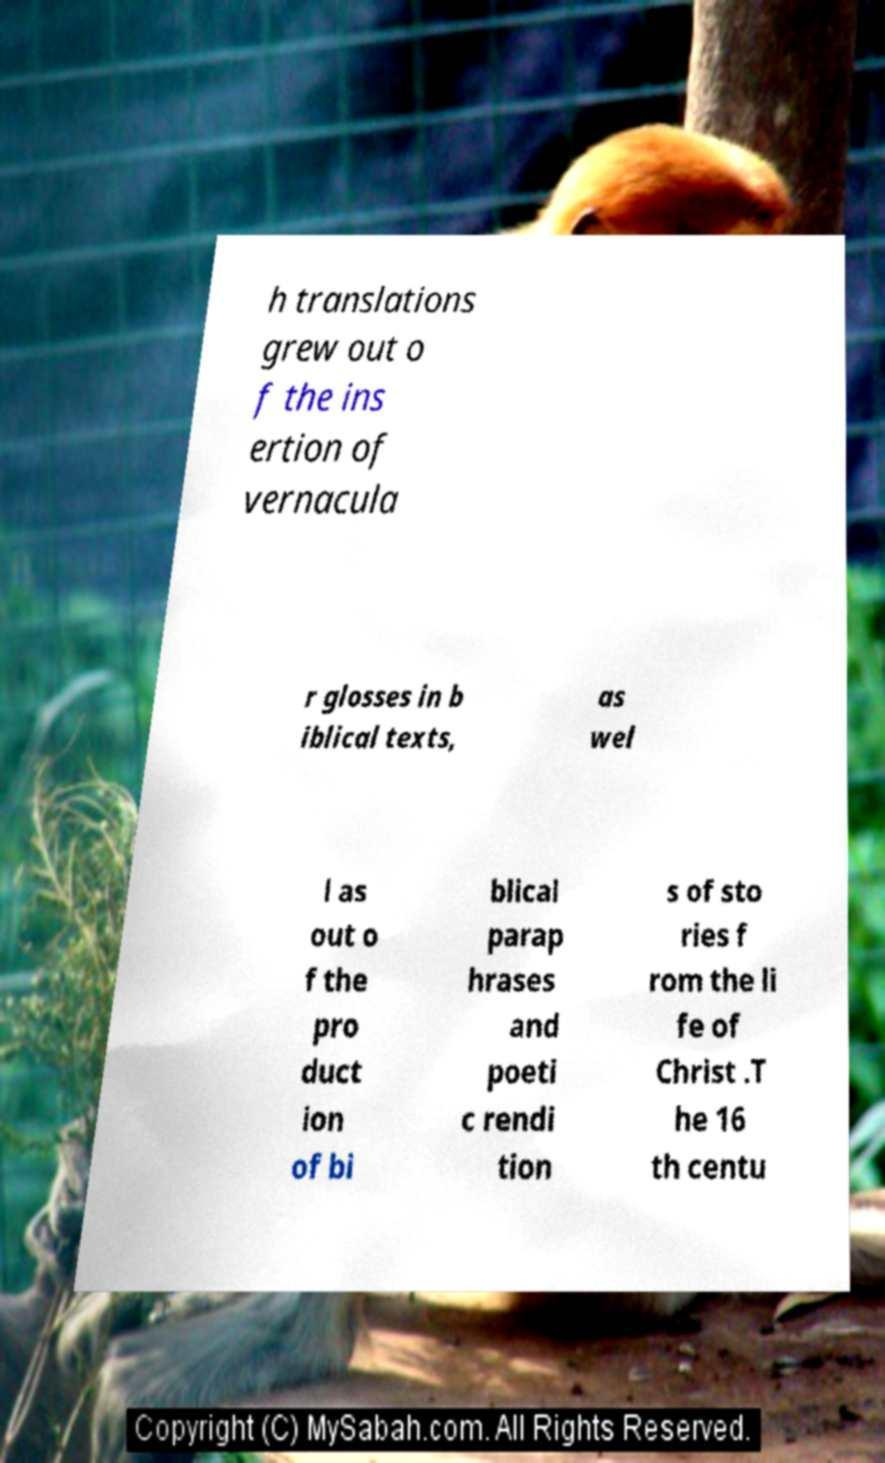Can you accurately transcribe the text from the provided image for me? h translations grew out o f the ins ertion of vernacula r glosses in b iblical texts, as wel l as out o f the pro duct ion of bi blical parap hrases and poeti c rendi tion s of sto ries f rom the li fe of Christ .T he 16 th centu 